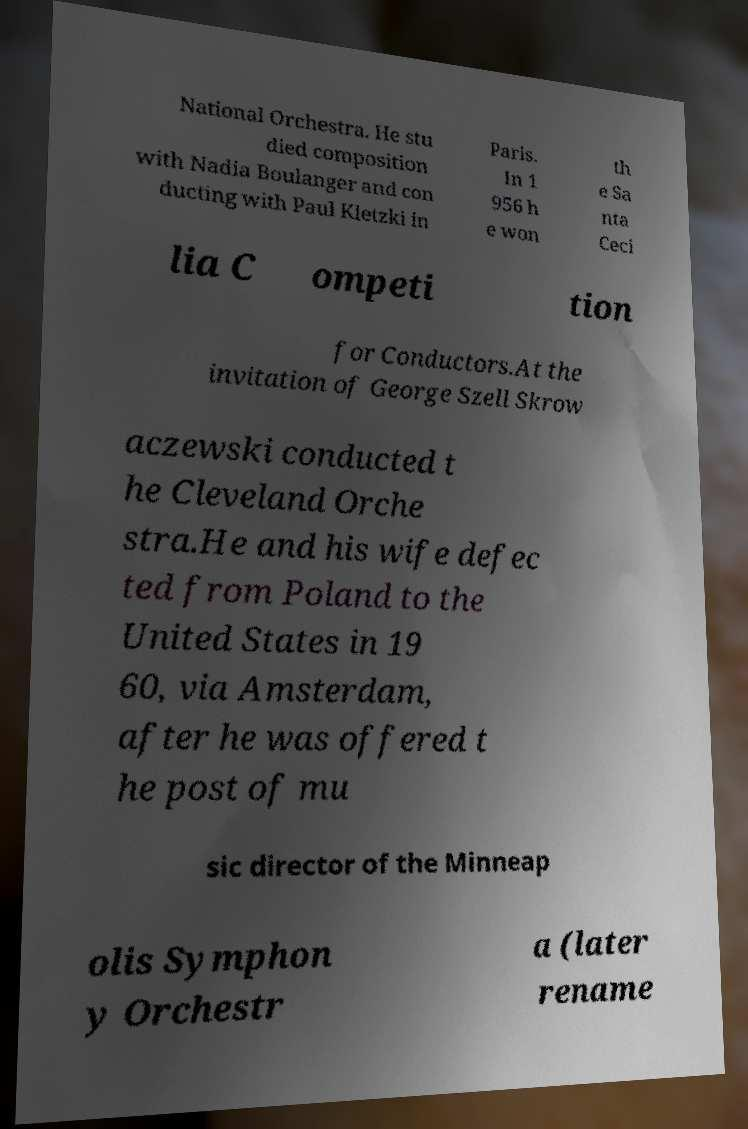There's text embedded in this image that I need extracted. Can you transcribe it verbatim? National Orchestra. He stu died composition with Nadia Boulanger and con ducting with Paul Kletzki in Paris. In 1 956 h e won th e Sa nta Ceci lia C ompeti tion for Conductors.At the invitation of George Szell Skrow aczewski conducted t he Cleveland Orche stra.He and his wife defec ted from Poland to the United States in 19 60, via Amsterdam, after he was offered t he post of mu sic director of the Minneap olis Symphon y Orchestr a (later rename 